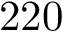<formula> <loc_0><loc_0><loc_500><loc_500>2 2 0</formula> 